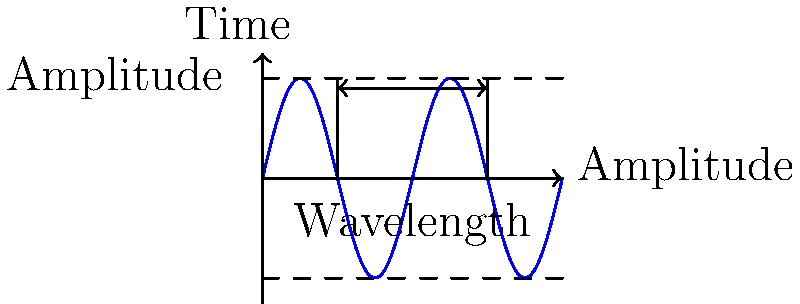Imagine you're creating a punk-rave track inspired by Little Big's energetic style. The sound engineer shows you this waveform representation of a bass synth. How would changing the amplitude of this wave affect the sound, and what aspect of the wave represents frequency? Let's break this down step-by-step:

1. Amplitude:
   - The amplitude of a sound wave is represented by the height of the wave from its center line to its peak or trough.
   - In the diagram, it's the distance from the horizontal axis to the top or bottom of the wave.
   - Changing the amplitude affects the volume or loudness of the sound.
   - If we increase the amplitude, the sound would become louder, which is crucial for Little Big's high-energy performances.

2. Frequency:
   - The frequency of a sound wave is represented by how often the wave repeats in a given time period.
   - In the diagram, it's shown by the wavelength, which is the distance between two consecutive peaks or troughs.
   - The wavelength is labeled in the diagram, and it's inversely related to frequency.
   - A shorter wavelength means a higher frequency, which would result in a higher pitch.

3. Effect on sound:
   - Increasing amplitude would make the bass synth louder, potentially adding more impact to the track.
   - Changing frequency would alter the pitch of the bass synth, which could be used to create different notes or effects in the punk-rave style.

4. Relevance to Little Big:
   - Little Big's music often features prominent bass lines and synthesizer sounds.
   - Understanding these wave properties could help in creating sounds similar to those used in their eccentric and energetic tracks.
Answer: Changing amplitude affects volume; frequency is represented by wavelength. 